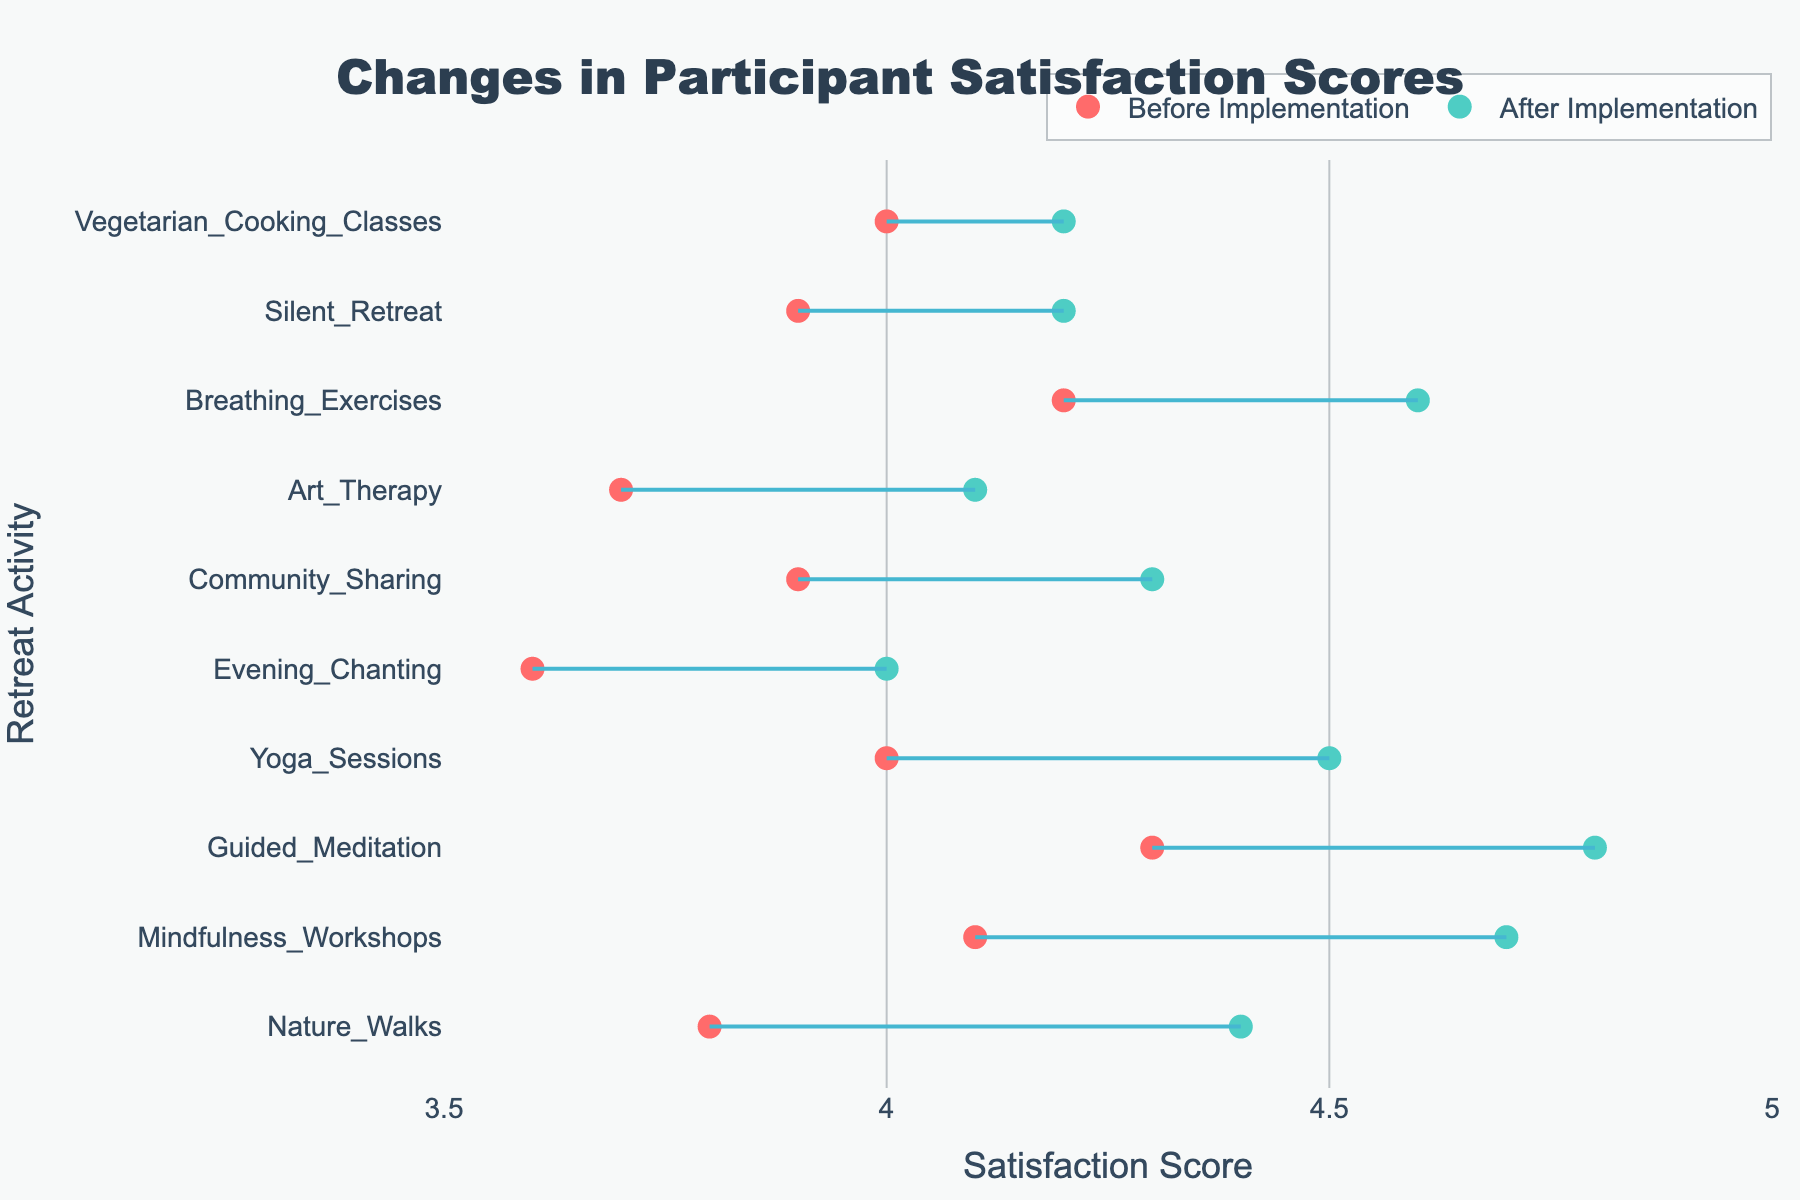What is the title of the plot? The title is located at the top of the plot and describes the main content of the figure.
Answer: Changes in Participant Satisfaction Scores What is the highest satisfaction score before implementation? Looking at the position of the dots on the x-axis for "Before Implementation", identify the highest value. It corresponds to Breathing Exercises.
Answer: 4.2 Which activity showed the least improvement in satisfaction scores? To determine this, look for the smallest difference between the "After Implementation" and "Before Implementation" scores, emphasizing the smallest distance between the red and green dots connected by a line. This occurs at Silent Retreat.
Answer: Silent Retreat What is the average satisfaction score before implementation across all activities? Sum all "Before Implementation" scores and divide by the number of activities. (4.3 + 4.0 + 3.8 + 4.1 + 3.9 + 3.7 + 4.0 + 3.6 + 3.9 + 4.2) / 10 = 3.95
Answer: 3.95 Which activity improved to a score of 4.7 after implementation? Look at the green dots on the plot to find which activity corresponds to a satisfaction score of 4.7. This is labeled as Mindfulness Workshops.
Answer: Mindfulness Workshops What is the range of satisfaction scores before implementation? Identify the smallest and largest scores for "Before Implementation", then subtract the smallest from the largest value. 4.3 (highest) - 3.6 (lowest) = 0.7
Answer: 0.7 Which activity had the largest increase in satisfaction score after implementation? Identify which activity has the largest distance between the "Before Implementation" and "After Implementation" scores typically indicated by the length of the connecting line. This is Nature Walks.
Answer: Nature Walks How many activities had an after-implementation score of 4.5 or higher? Count the number of green dots that are positioned at 4.5 or higher on the x-axis.
Answer: 4 What is the satisfaction score for Art Therapy before and after implementation? Locate the red and green dots for Art Therapy and note their positions on the x-axis.
Answer: 3.7 (before), 4.1 (after) Which activities have a satisfaction score of 4.2 after implementation? Identify the activities by locating the green dots on the x-axis at 4.2. These are Vegetarian Cooking Classes and Silent Retreat.
Answer: Vegetarian Cooking Classes, Silent Retreat 